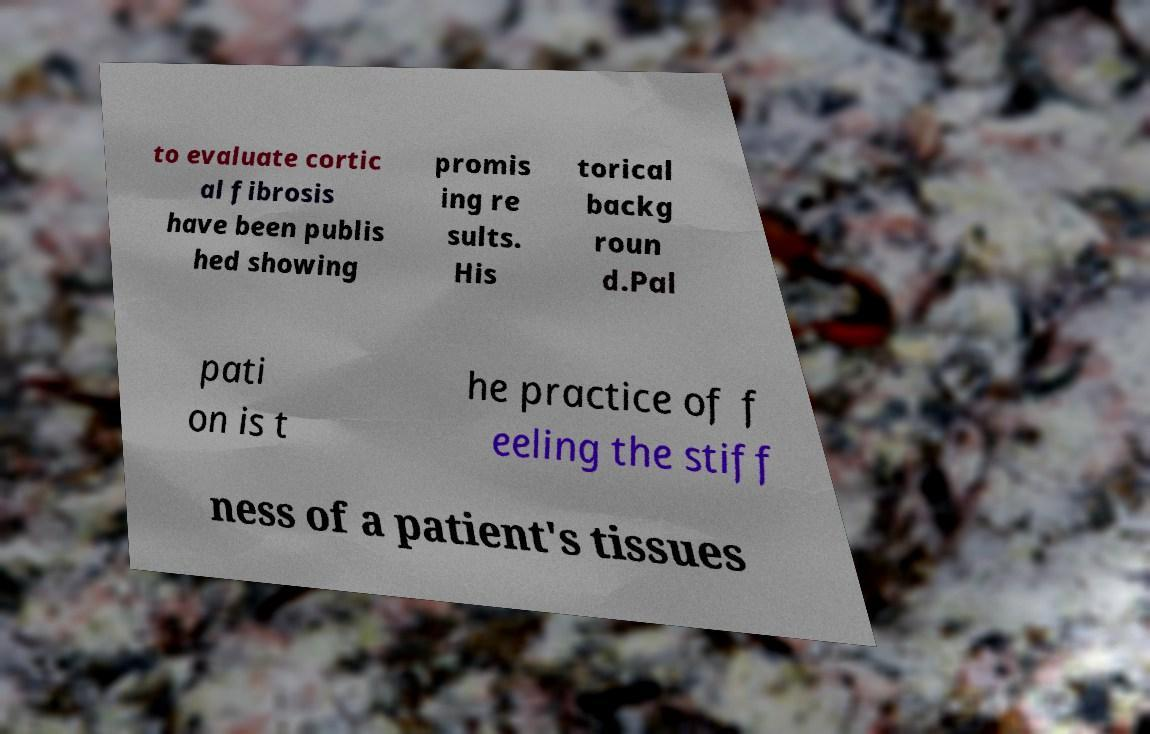There's text embedded in this image that I need extracted. Can you transcribe it verbatim? to evaluate cortic al fibrosis have been publis hed showing promis ing re sults. His torical backg roun d.Pal pati on is t he practice of f eeling the stiff ness of a patient's tissues 